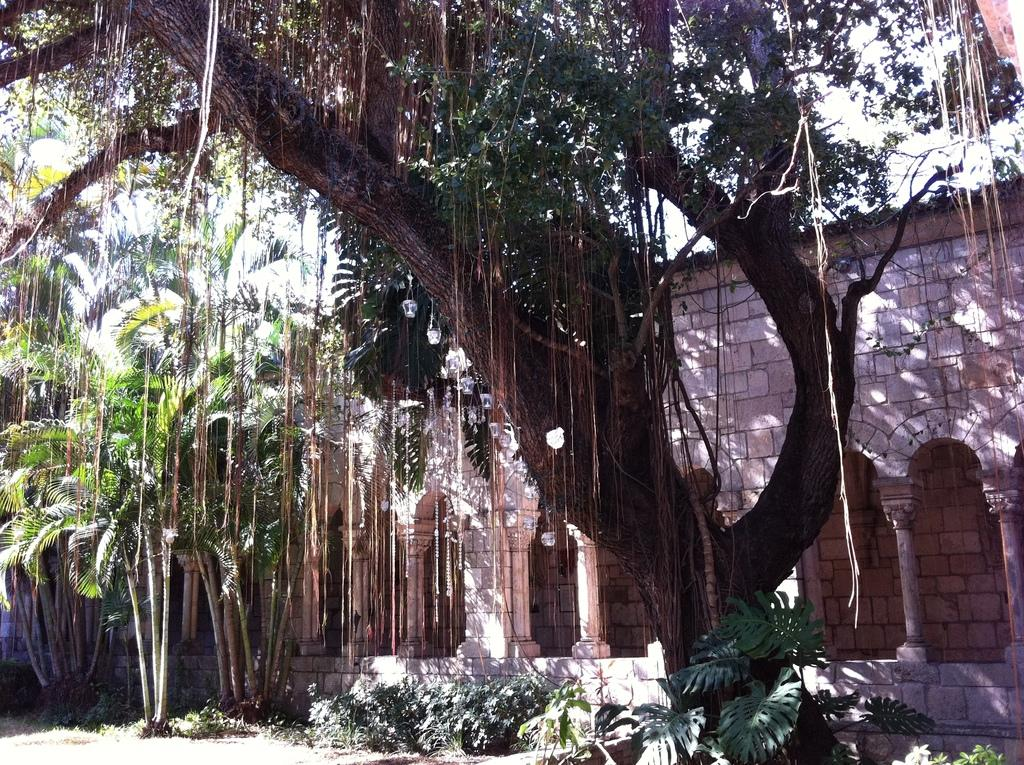What can be seen in the background of the image? In the background of the image, there is a wall and pillars. What type of vegetation is visible in the image? Trees are visible in the image, and plants can be seen in the bottom portion of the image. What is visible at the bottom of the image? The ground is visible in the bottom portion of the image. How many frogs are sitting on the bell in the image? There is no bell or frogs present in the image. What type of place is depicted in the image? The image does not depict a specific place; it shows a wall, pillars, trees, plants, and the ground. 